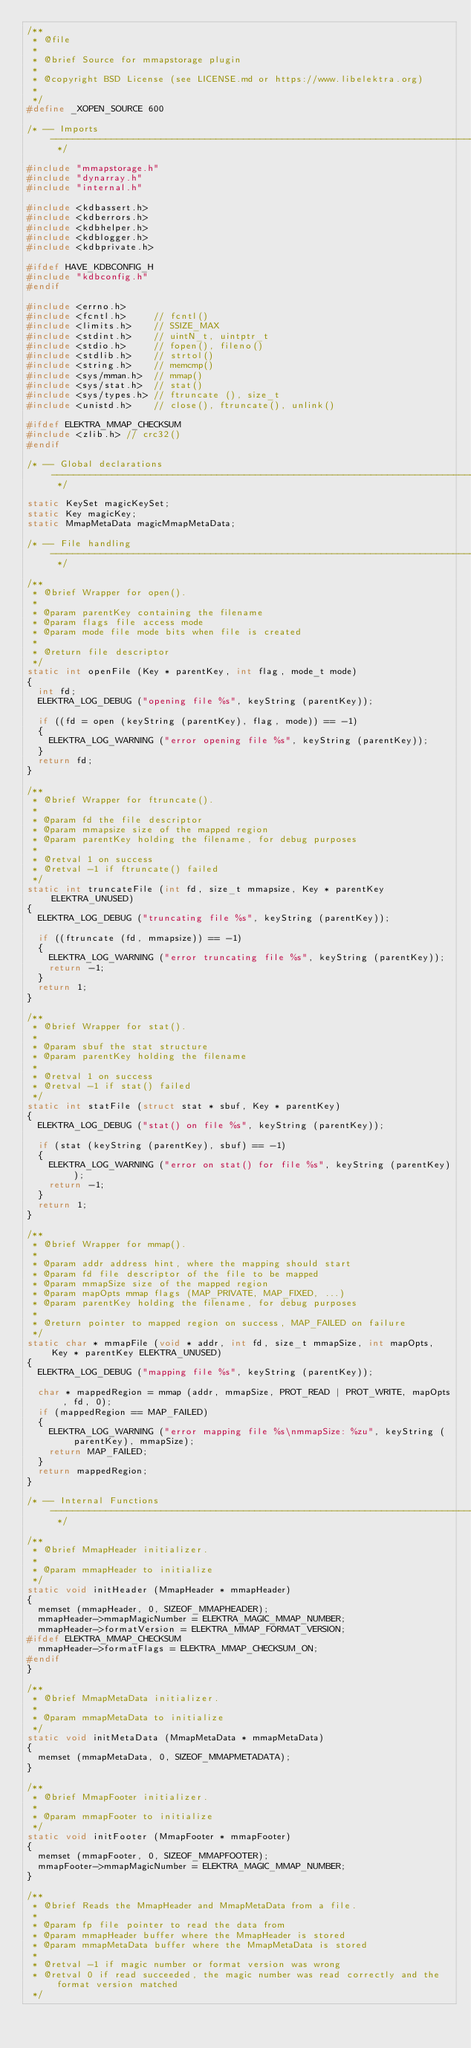Convert code to text. <code><loc_0><loc_0><loc_500><loc_500><_C_>/**
 * @file
 *
 * @brief Source for mmapstorage plugin
 *
 * @copyright BSD License (see LICENSE.md or https://www.libelektra.org)
 *
 */
#define _XOPEN_SOURCE 600

/* -- Imports --------------------------------------------------------------------------------------------------------------------------- */

#include "mmapstorage.h"
#include "dynarray.h"
#include "internal.h"

#include <kdbassert.h>
#include <kdberrors.h>
#include <kdbhelper.h>
#include <kdblogger.h>
#include <kdbprivate.h>

#ifdef HAVE_KDBCONFIG_H
#include "kdbconfig.h"
#endif

#include <errno.h>
#include <fcntl.h>     // fcntl()
#include <limits.h>    // SSIZE_MAX
#include <stdint.h>    // uintN_t, uintptr_t
#include <stdio.h>     // fopen(), fileno()
#include <stdlib.h>    // strtol()
#include <string.h>    // memcmp()
#include <sys/mman.h>  // mmap()
#include <sys/stat.h>  // stat()
#include <sys/types.h> // ftruncate (), size_t
#include <unistd.h>    // close(), ftruncate(), unlink()

#ifdef ELEKTRA_MMAP_CHECKSUM
#include <zlib.h> // crc32()
#endif

/* -- Global declarations---------------------------------------------------------------------------------------------------------------- */

static KeySet magicKeySet;
static Key magicKey;
static MmapMetaData magicMmapMetaData;

/* -- File handling --------------------------------------------------------------------------------------------------------------------- */

/**
 * @brief Wrapper for open().
 *
 * @param parentKey containing the filename
 * @param flags file access mode
 * @param mode file mode bits when file is created
 *
 * @return file descriptor
 */
static int openFile (Key * parentKey, int flag, mode_t mode)
{
	int fd;
	ELEKTRA_LOG_DEBUG ("opening file %s", keyString (parentKey));

	if ((fd = open (keyString (parentKey), flag, mode)) == -1)
	{
		ELEKTRA_LOG_WARNING ("error opening file %s", keyString (parentKey));
	}
	return fd;
}

/**
 * @brief Wrapper for ftruncate().
 *
 * @param fd the file descriptor
 * @param mmapsize size of the mapped region
 * @param parentKey holding the filename, for debug purposes
 *
 * @retval 1 on success
 * @retval -1 if ftruncate() failed
 */
static int truncateFile (int fd, size_t mmapsize, Key * parentKey ELEKTRA_UNUSED)
{
	ELEKTRA_LOG_DEBUG ("truncating file %s", keyString (parentKey));

	if ((ftruncate (fd, mmapsize)) == -1)
	{
		ELEKTRA_LOG_WARNING ("error truncating file %s", keyString (parentKey));
		return -1;
	}
	return 1;
}

/**
 * @brief Wrapper for stat().
 *
 * @param sbuf the stat structure
 * @param parentKey holding the filename
 *
 * @retval 1 on success
 * @retval -1 if stat() failed
 */
static int statFile (struct stat * sbuf, Key * parentKey)
{
	ELEKTRA_LOG_DEBUG ("stat() on file %s", keyString (parentKey));

	if (stat (keyString (parentKey), sbuf) == -1)
	{
		ELEKTRA_LOG_WARNING ("error on stat() for file %s", keyString (parentKey));
		return -1;
	}
	return 1;
}

/**
 * @brief Wrapper for mmap().
 *
 * @param addr address hint, where the mapping should start
 * @param fd file descriptor of the file to be mapped
 * @param mmapSize size of the mapped region
 * @param mapOpts mmap flags (MAP_PRIVATE, MAP_FIXED, ...)
 * @param parentKey holding the filename, for debug purposes
 *
 * @return pointer to mapped region on success, MAP_FAILED on failure
 */
static char * mmapFile (void * addr, int fd, size_t mmapSize, int mapOpts, Key * parentKey ELEKTRA_UNUSED)
{
	ELEKTRA_LOG_DEBUG ("mapping file %s", keyString (parentKey));

	char * mappedRegion = mmap (addr, mmapSize, PROT_READ | PROT_WRITE, mapOpts, fd, 0);
	if (mappedRegion == MAP_FAILED)
	{
		ELEKTRA_LOG_WARNING ("error mapping file %s\nmmapSize: %zu", keyString (parentKey), mmapSize);
		return MAP_FAILED;
	}
	return mappedRegion;
}

/* -- Internal Functions  --------------------------------------------------------------------------------------------------------------- */

/**
 * @brief MmapHeader initializer.
 *
 * @param mmapHeader to initialize
 */
static void initHeader (MmapHeader * mmapHeader)
{
	memset (mmapHeader, 0, SIZEOF_MMAPHEADER);
	mmapHeader->mmapMagicNumber = ELEKTRA_MAGIC_MMAP_NUMBER;
	mmapHeader->formatVersion = ELEKTRA_MMAP_FORMAT_VERSION;
#ifdef ELEKTRA_MMAP_CHECKSUM
	mmapHeader->formatFlags = ELEKTRA_MMAP_CHECKSUM_ON;
#endif
}

/**
 * @brief MmapMetaData initializer.
 *
 * @param mmapMetaData to initialize
 */
static void initMetaData (MmapMetaData * mmapMetaData)
{
	memset (mmapMetaData, 0, SIZEOF_MMAPMETADATA);
}

/**
 * @brief MmapFooter initializer.
 *
 * @param mmapFooter to initialize
 */
static void initFooter (MmapFooter * mmapFooter)
{
	memset (mmapFooter, 0, SIZEOF_MMAPFOOTER);
	mmapFooter->mmapMagicNumber = ELEKTRA_MAGIC_MMAP_NUMBER;
}

/**
 * @brief Reads the MmapHeader and MmapMetaData from a file.
 *
 * @param fp file pointer to read the data from
 * @param mmapHeader buffer where the MmapHeader is stored
 * @param mmapMetaData buffer where the MmapMetaData is stored
 *
 * @retval -1 if magic number or format version was wrong
 * @retval 0 if read succeeded, the magic number was read correctly and the format version matched
 */</code> 